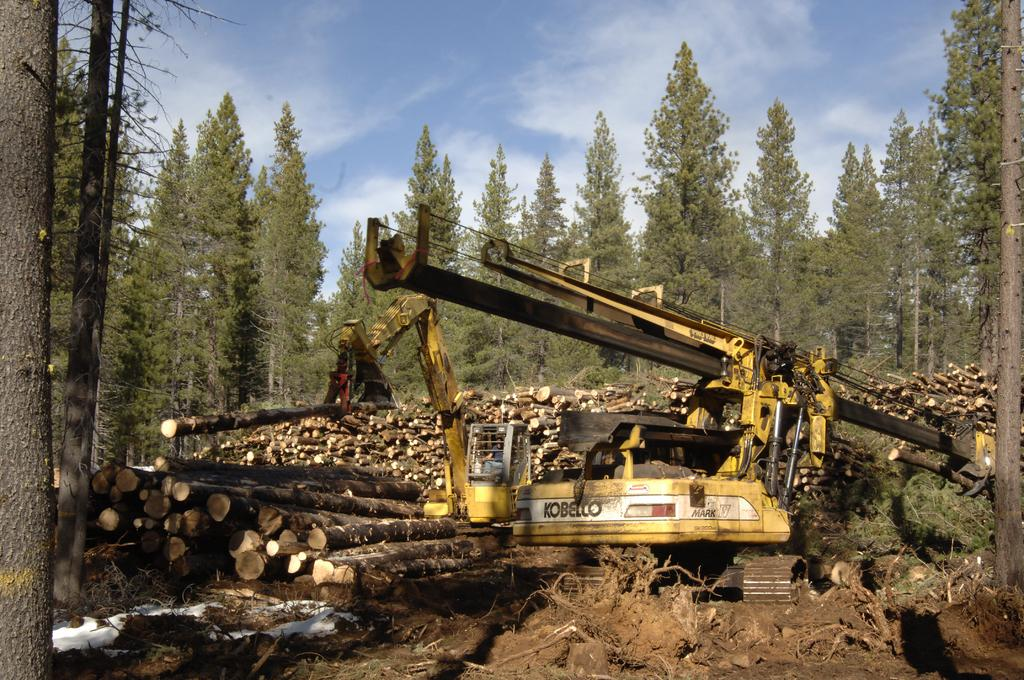Provide a one-sentence caption for the provided image. A large Kobelco excavator is surrounded by man tree logs that have recently been cut down. 